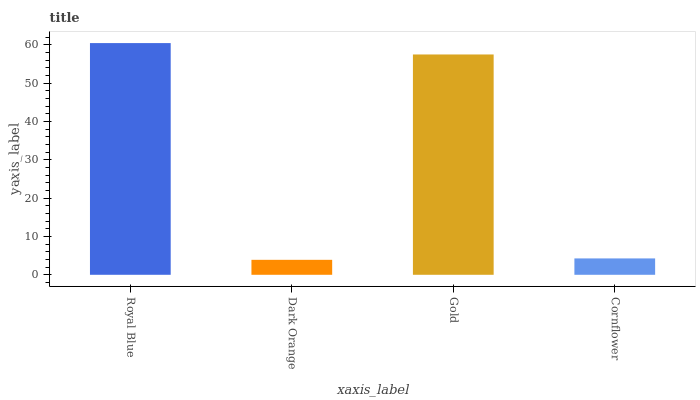Is Dark Orange the minimum?
Answer yes or no. Yes. Is Royal Blue the maximum?
Answer yes or no. Yes. Is Gold the minimum?
Answer yes or no. No. Is Gold the maximum?
Answer yes or no. No. Is Gold greater than Dark Orange?
Answer yes or no. Yes. Is Dark Orange less than Gold?
Answer yes or no. Yes. Is Dark Orange greater than Gold?
Answer yes or no. No. Is Gold less than Dark Orange?
Answer yes or no. No. Is Gold the high median?
Answer yes or no. Yes. Is Cornflower the low median?
Answer yes or no. Yes. Is Cornflower the high median?
Answer yes or no. No. Is Gold the low median?
Answer yes or no. No. 